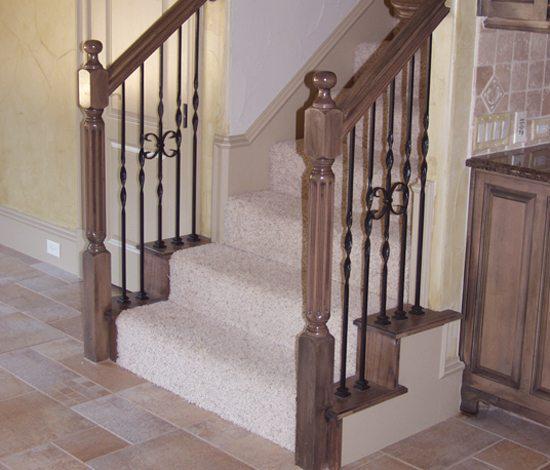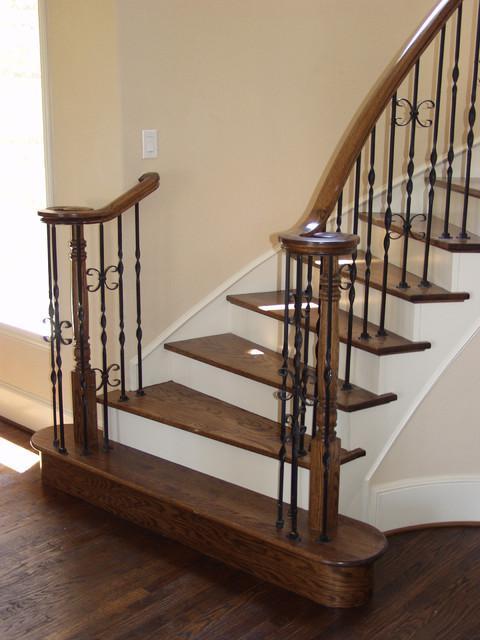The first image is the image on the left, the second image is the image on the right. Considering the images on both sides, is "The left staircase is straight and the right staircase is curved." valid? Answer yes or no. Yes. The first image is the image on the left, the second image is the image on the right. Assess this claim about the two images: "One of the images shows a straight staircase and the other shows a curved staircase.". Correct or not? Answer yes or no. Yes. 